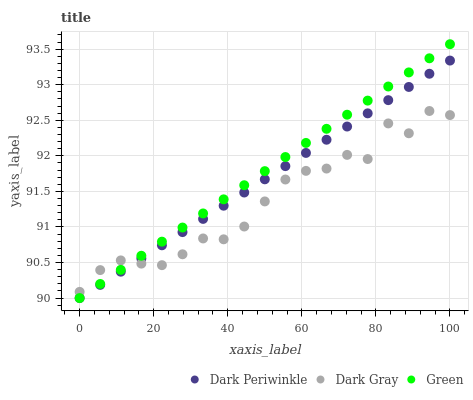Does Dark Gray have the minimum area under the curve?
Answer yes or no. Yes. Does Green have the maximum area under the curve?
Answer yes or no. Yes. Does Dark Periwinkle have the minimum area under the curve?
Answer yes or no. No. Does Dark Periwinkle have the maximum area under the curve?
Answer yes or no. No. Is Dark Periwinkle the smoothest?
Answer yes or no. Yes. Is Dark Gray the roughest?
Answer yes or no. Yes. Is Green the smoothest?
Answer yes or no. No. Is Green the roughest?
Answer yes or no. No. Does Green have the lowest value?
Answer yes or no. Yes. Does Green have the highest value?
Answer yes or no. Yes. Does Dark Periwinkle have the highest value?
Answer yes or no. No. Does Green intersect Dark Gray?
Answer yes or no. Yes. Is Green less than Dark Gray?
Answer yes or no. No. Is Green greater than Dark Gray?
Answer yes or no. No. 